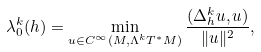<formula> <loc_0><loc_0><loc_500><loc_500>\lambda ^ { k } _ { 0 } ( h ) = \min _ { u \in C ^ { \infty } ( M , \Lambda ^ { k } T ^ { * } M ) } \frac { ( \Delta ^ { k } _ { h } u , u ) } { \| u \| ^ { 2 } } ,</formula> 